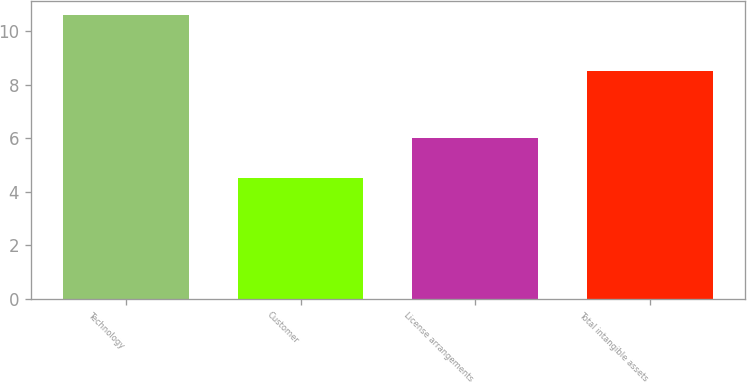Convert chart. <chart><loc_0><loc_0><loc_500><loc_500><bar_chart><fcel>Technology<fcel>Customer<fcel>License arrangements<fcel>Total intangible assets<nl><fcel>10.6<fcel>4.5<fcel>6<fcel>8.5<nl></chart> 